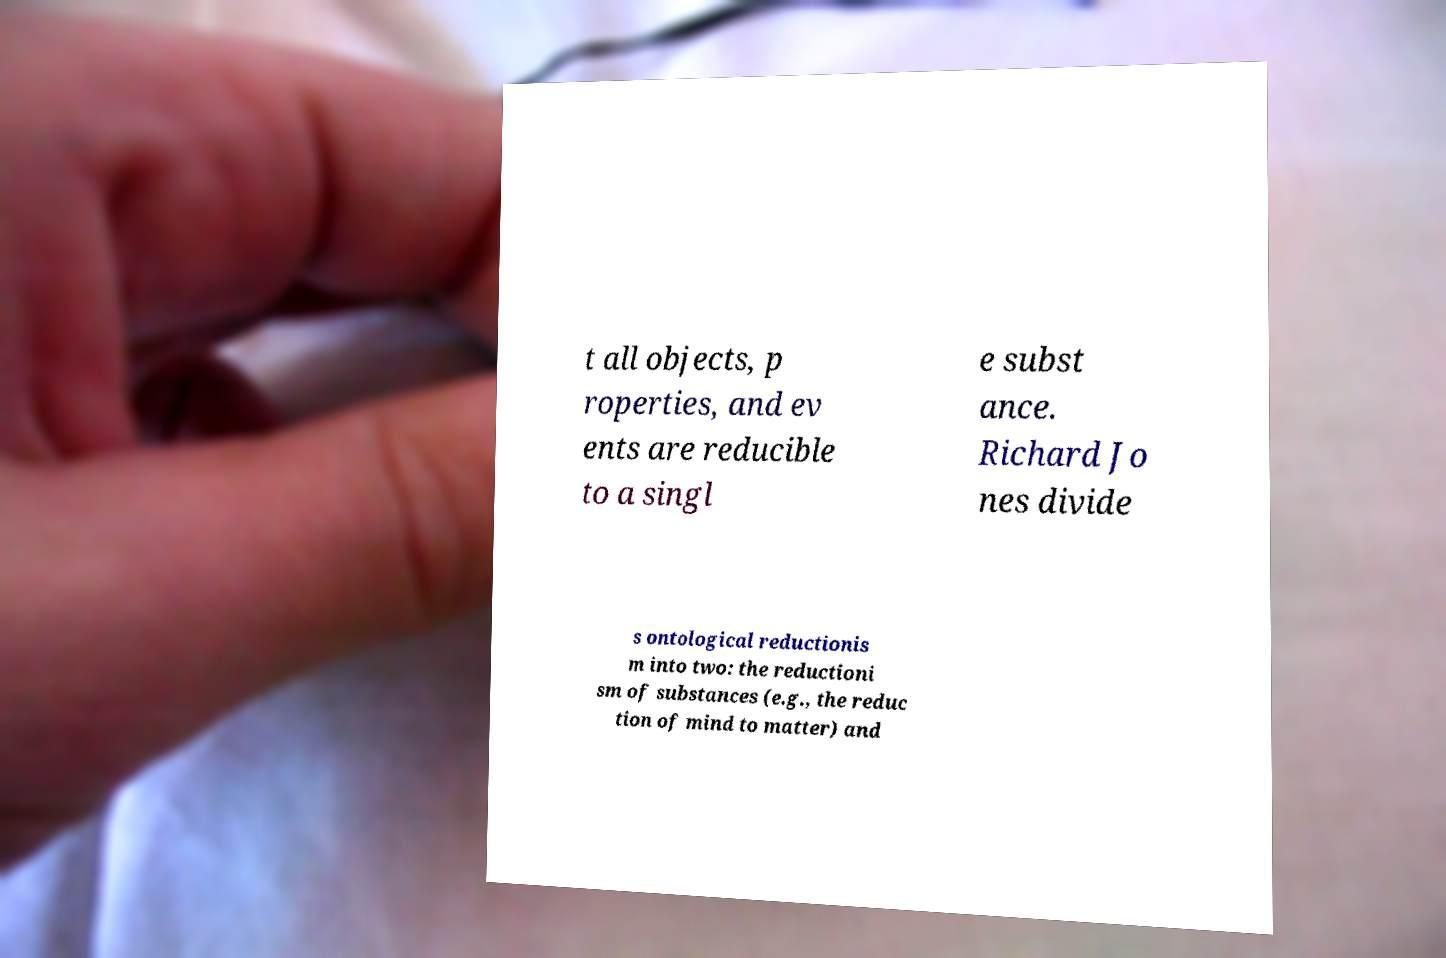Can you accurately transcribe the text from the provided image for me? t all objects, p roperties, and ev ents are reducible to a singl e subst ance. Richard Jo nes divide s ontological reductionis m into two: the reductioni sm of substances (e.g., the reduc tion of mind to matter) and 